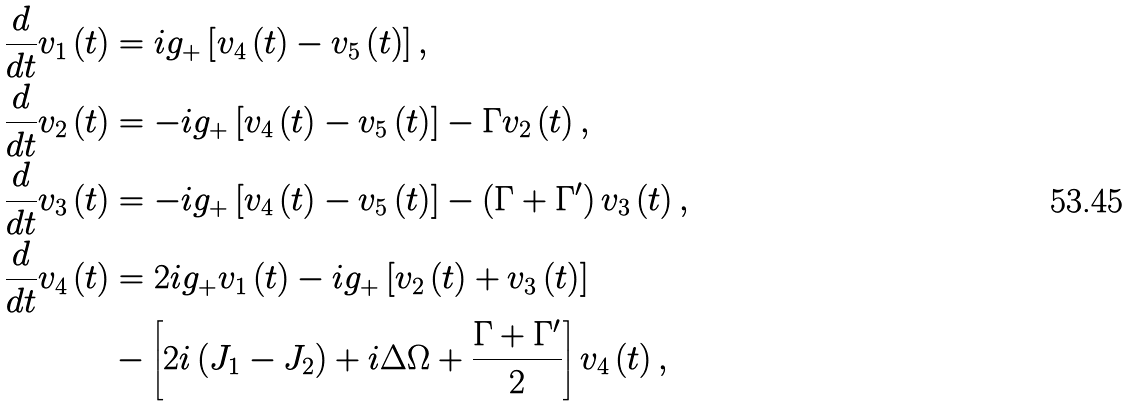Convert formula to latex. <formula><loc_0><loc_0><loc_500><loc_500>\frac { d } { d t } v _ { 1 } \left ( t \right ) & = i g _ { + } \left [ v _ { 4 } \left ( t \right ) - v _ { 5 } \left ( t \right ) \right ] , \\ \frac { d } { d t } v _ { 2 } \left ( t \right ) & = - i g _ { + } \left [ v _ { 4 } \left ( t \right ) - v _ { 5 } \left ( t \right ) \right ] - \Gamma v _ { 2 } \left ( t \right ) , \\ \frac { d } { d t } v _ { 3 } \left ( t \right ) & = - i g _ { + } \left [ v _ { 4 } \left ( t \right ) - v _ { 5 } \left ( t \right ) \right ] - \left ( \Gamma + \Gamma ^ { \prime } \right ) v _ { 3 } \left ( t \right ) , \\ \frac { d } { d t } v _ { 4 } \left ( t \right ) & = 2 i g _ { + } v _ { 1 } \left ( t \right ) - i g _ { + } \left [ v _ { 2 } \left ( t \right ) + v _ { 3 } \left ( t \right ) \right ] \\ & - \left [ 2 i \left ( J _ { 1 } - J _ { 2 } \right ) + i \Delta \Omega + \frac { \Gamma + \Gamma ^ { \prime } } { 2 } \right ] v _ { 4 } \left ( t \right ) ,</formula> 